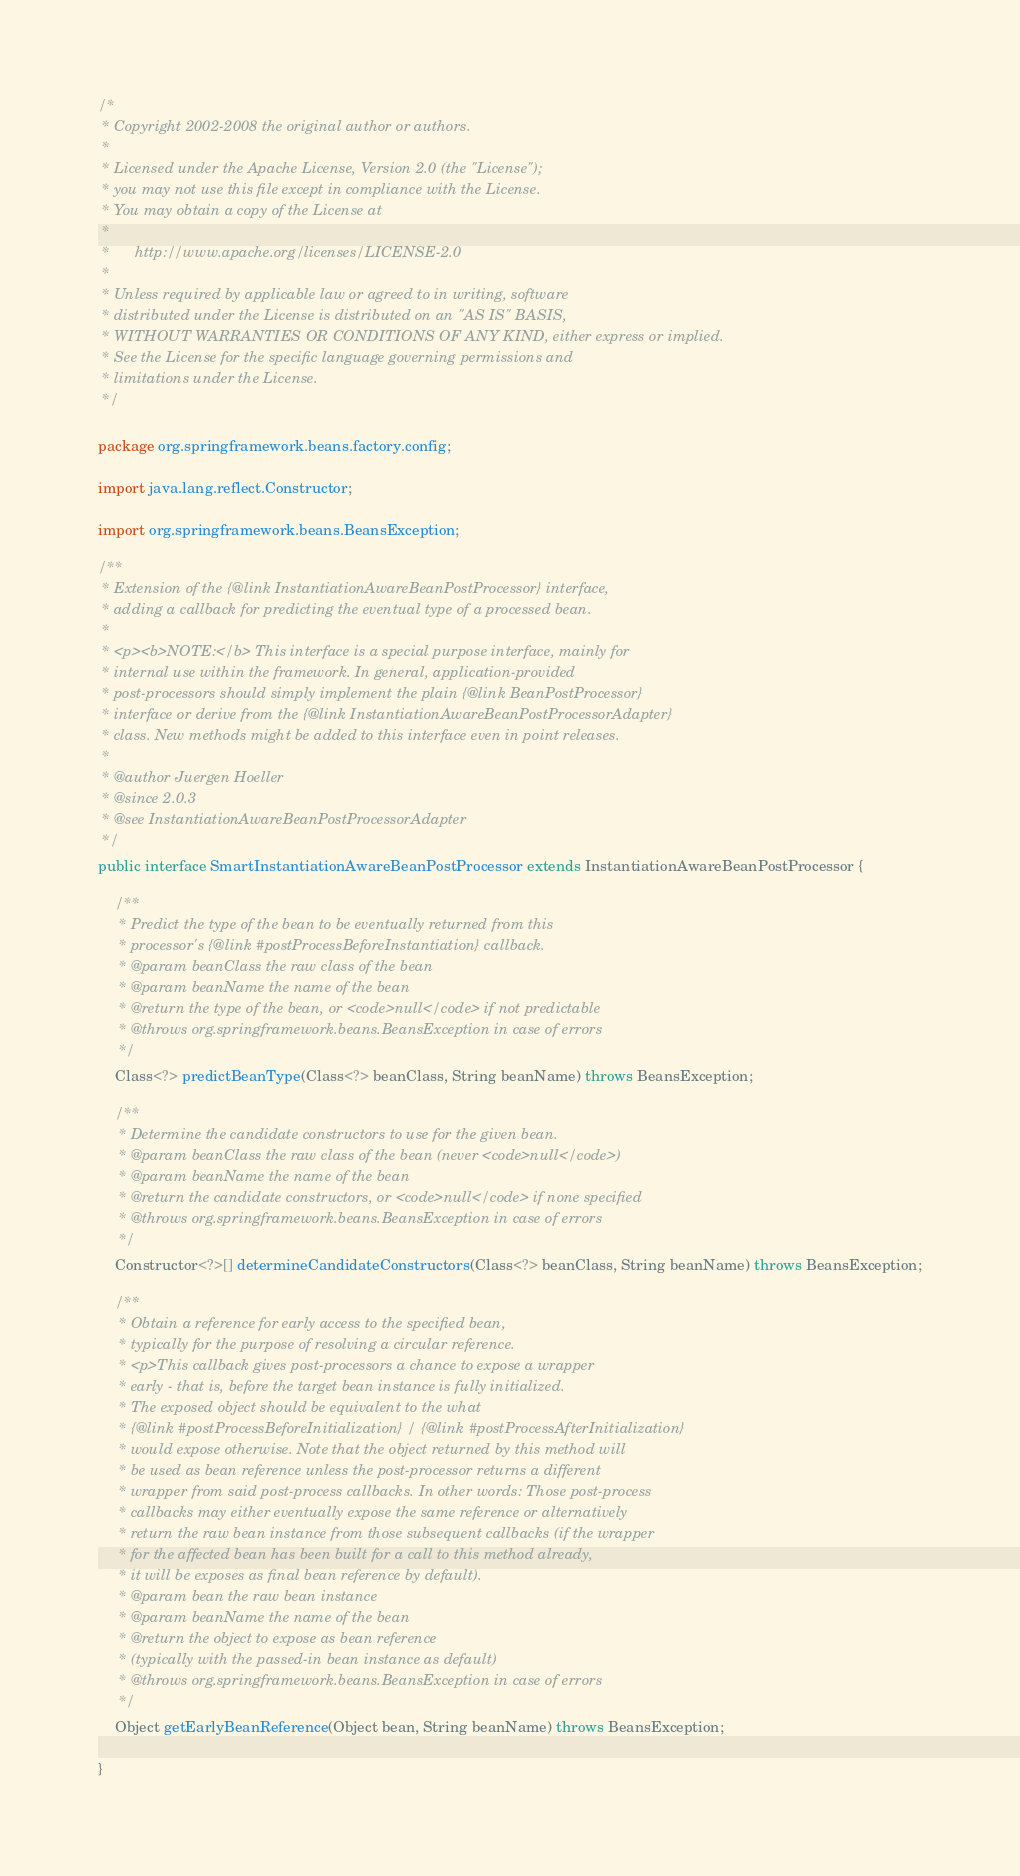<code> <loc_0><loc_0><loc_500><loc_500><_Java_>/*
 * Copyright 2002-2008 the original author or authors.
 *
 * Licensed under the Apache License, Version 2.0 (the "License");
 * you may not use this file except in compliance with the License.
 * You may obtain a copy of the License at
 *
 *      http://www.apache.org/licenses/LICENSE-2.0
 *
 * Unless required by applicable law or agreed to in writing, software
 * distributed under the License is distributed on an "AS IS" BASIS,
 * WITHOUT WARRANTIES OR CONDITIONS OF ANY KIND, either express or implied.
 * See the License for the specific language governing permissions and
 * limitations under the License.
 */

package org.springframework.beans.factory.config;

import java.lang.reflect.Constructor;

import org.springframework.beans.BeansException;

/**
 * Extension of the {@link InstantiationAwareBeanPostProcessor} interface,
 * adding a callback for predicting the eventual type of a processed bean.
 *
 * <p><b>NOTE:</b> This interface is a special purpose interface, mainly for
 * internal use within the framework. In general, application-provided
 * post-processors should simply implement the plain {@link BeanPostProcessor}
 * interface or derive from the {@link InstantiationAwareBeanPostProcessorAdapter}
 * class. New methods might be added to this interface even in point releases.
 *
 * @author Juergen Hoeller
 * @since 2.0.3
 * @see InstantiationAwareBeanPostProcessorAdapter
 */
public interface SmartInstantiationAwareBeanPostProcessor extends InstantiationAwareBeanPostProcessor {

	/**
	 * Predict the type of the bean to be eventually returned from this
	 * processor's {@link #postProcessBeforeInstantiation} callback.
	 * @param beanClass the raw class of the bean
	 * @param beanName the name of the bean
	 * @return the type of the bean, or <code>null</code> if not predictable
	 * @throws org.springframework.beans.BeansException in case of errors
	 */
	Class<?> predictBeanType(Class<?> beanClass, String beanName) throws BeansException;

	/**
	 * Determine the candidate constructors to use for the given bean.
	 * @param beanClass the raw class of the bean (never <code>null</code>)
	 * @param beanName the name of the bean
	 * @return the candidate constructors, or <code>null</code> if none specified
	 * @throws org.springframework.beans.BeansException in case of errors
	 */
	Constructor<?>[] determineCandidateConstructors(Class<?> beanClass, String beanName) throws BeansException;

	/**
	 * Obtain a reference for early access to the specified bean,
	 * typically for the purpose of resolving a circular reference.
	 * <p>This callback gives post-processors a chance to expose a wrapper
	 * early - that is, before the target bean instance is fully initialized.
	 * The exposed object should be equivalent to the what
	 * {@link #postProcessBeforeInitialization} / {@link #postProcessAfterInitialization}
	 * would expose otherwise. Note that the object returned by this method will
	 * be used as bean reference unless the post-processor returns a different
	 * wrapper from said post-process callbacks. In other words: Those post-process
	 * callbacks may either eventually expose the same reference or alternatively
	 * return the raw bean instance from those subsequent callbacks (if the wrapper
	 * for the affected bean has been built for a call to this method already,
	 * it will be exposes as final bean reference by default).
	 * @param bean the raw bean instance
	 * @param beanName the name of the bean
	 * @return the object to expose as bean reference
	 * (typically with the passed-in bean instance as default)
	 * @throws org.springframework.beans.BeansException in case of errors
	 */
	Object getEarlyBeanReference(Object bean, String beanName) throws BeansException;

}
</code> 